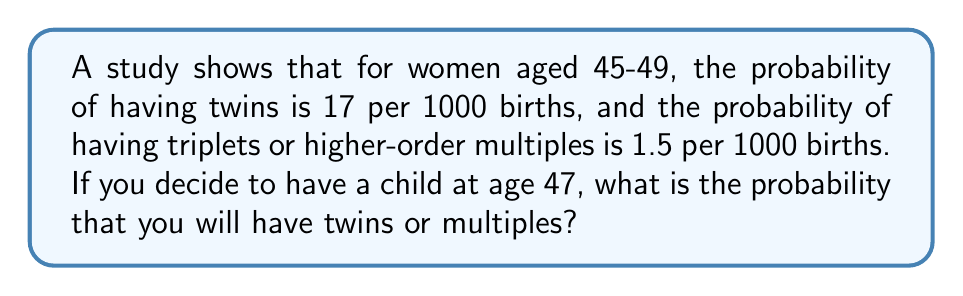Show me your answer to this math problem. Let's approach this step-by-step:

1) First, we need to convert the given probabilities to decimals:
   Probability of twins: $\frac{17}{1000} = 0.017$
   Probability of triplets or higher: $\frac{1.5}{1000} = 0.0015$

2) The question asks for the probability of having twins OR multiples. In probability theory, when we want the probability of one event OR another, and these events are mutually exclusive (can't happen at the same time), we add their individual probabilities.

3) The probability of having twins or multiples is the sum of:
   - The probability of having twins
   - The probability of having triplets or higher-order multiples

4) Let's calculate:
   $P(\text{twins or multiples}) = P(\text{twins}) + P(\text{triplets or higher})$
   $P(\text{twins or multiples}) = 0.017 + 0.0015 = 0.0185$

5) To convert this back to a percentage:
   $0.0185 \times 100\% = 1.85\%$

Therefore, the probability of having twins or multiples at age 47 is 0.0185 or 1.85%.
Answer: 0.0185 or 1.85% 